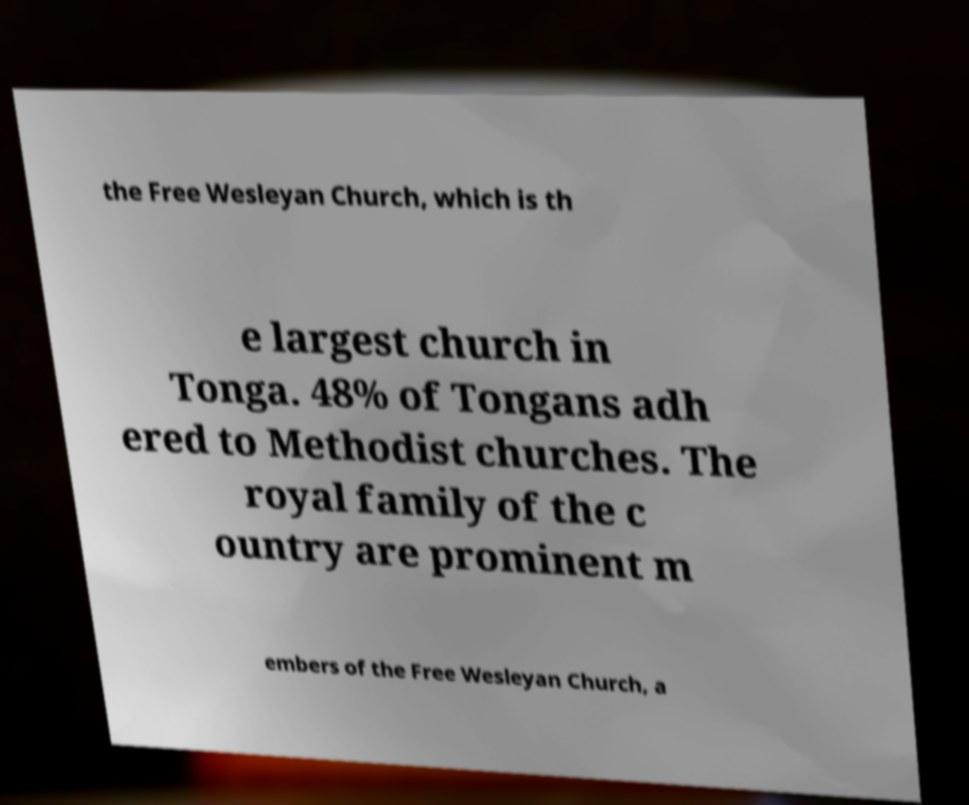Can you read and provide the text displayed in the image?This photo seems to have some interesting text. Can you extract and type it out for me? the Free Wesleyan Church, which is th e largest church in Tonga. 48% of Tongans adh ered to Methodist churches. The royal family of the c ountry are prominent m embers of the Free Wesleyan Church, a 